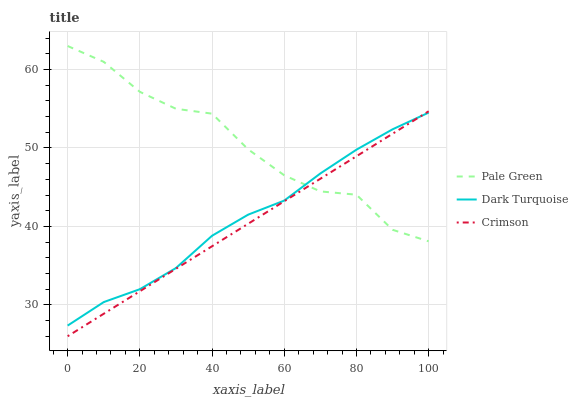Does Crimson have the minimum area under the curve?
Answer yes or no. Yes. Does Pale Green have the maximum area under the curve?
Answer yes or no. Yes. Does Dark Turquoise have the minimum area under the curve?
Answer yes or no. No. Does Dark Turquoise have the maximum area under the curve?
Answer yes or no. No. Is Crimson the smoothest?
Answer yes or no. Yes. Is Pale Green the roughest?
Answer yes or no. Yes. Is Dark Turquoise the smoothest?
Answer yes or no. No. Is Dark Turquoise the roughest?
Answer yes or no. No. Does Crimson have the lowest value?
Answer yes or no. Yes. Does Dark Turquoise have the lowest value?
Answer yes or no. No. Does Pale Green have the highest value?
Answer yes or no. Yes. Does Dark Turquoise have the highest value?
Answer yes or no. No. Does Dark Turquoise intersect Crimson?
Answer yes or no. Yes. Is Dark Turquoise less than Crimson?
Answer yes or no. No. Is Dark Turquoise greater than Crimson?
Answer yes or no. No. 